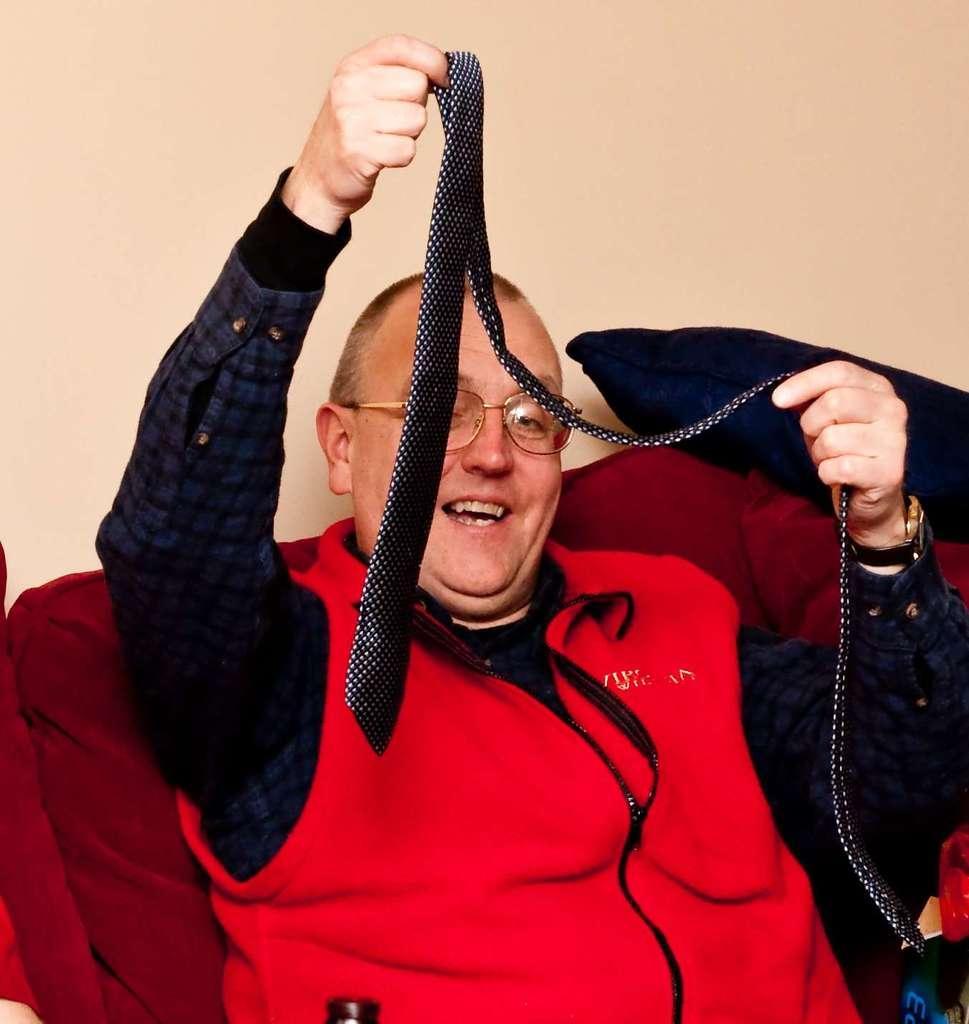Please provide a concise description of this image. In the picture I can see a person wearing red jacket is sitting in a sofa and holding an object in his hands and there is a pillow in the right corner. 